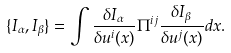<formula> <loc_0><loc_0><loc_500><loc_500>\{ I _ { \alpha } , I _ { \beta } \} = \int \frac { \delta I _ { \alpha } } { \delta u ^ { i } ( x ) } \Pi ^ { i j } \frac { \delta I _ { \beta } } { \delta u ^ { j } ( x ) } d x .</formula> 